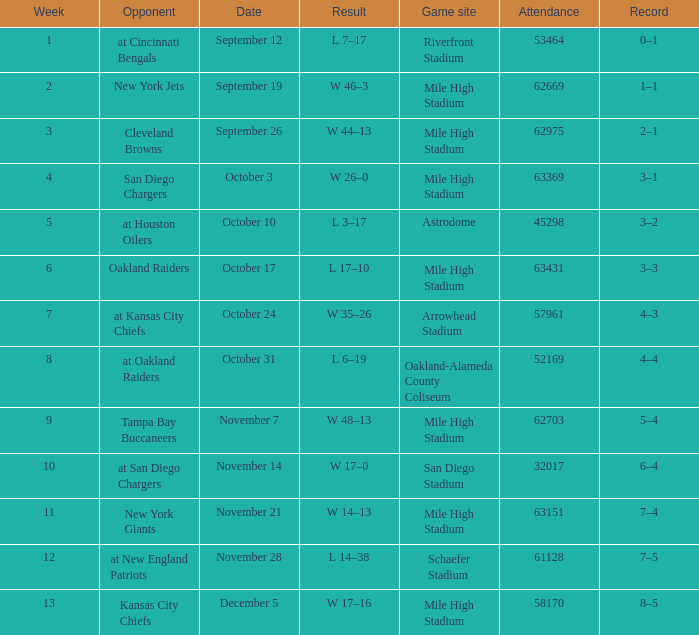What was the week number when the opponent was the New York Jets? 2.0. 